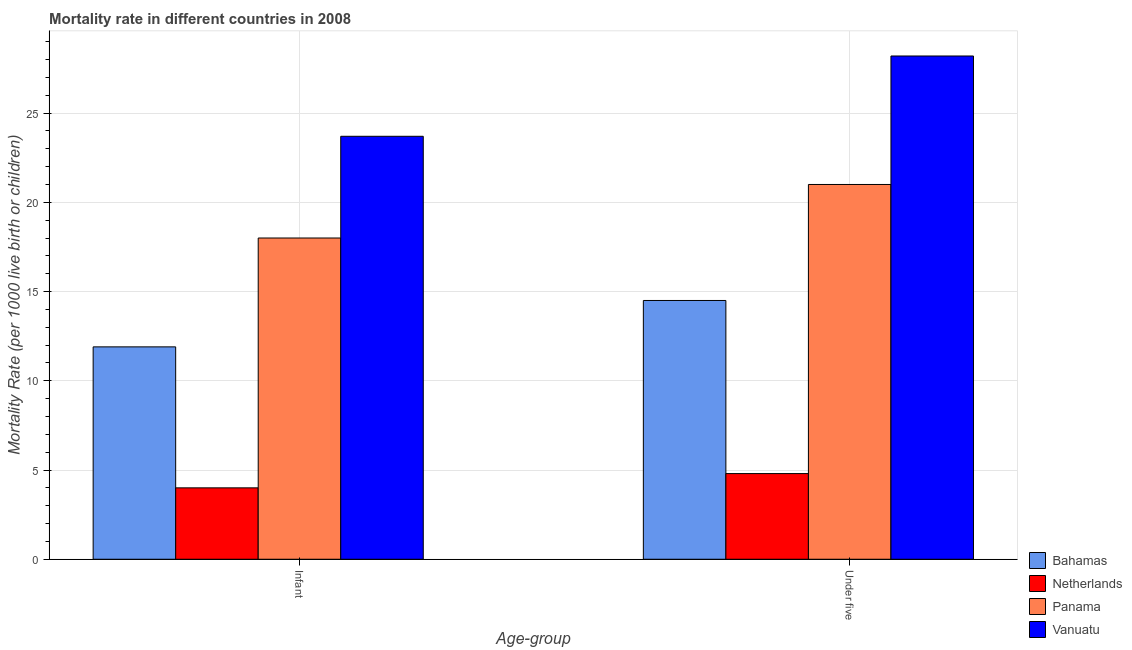How many different coloured bars are there?
Give a very brief answer. 4. Are the number of bars per tick equal to the number of legend labels?
Make the answer very short. Yes. Are the number of bars on each tick of the X-axis equal?
Offer a terse response. Yes. What is the label of the 2nd group of bars from the left?
Make the answer very short. Under five. What is the under-5 mortality rate in Vanuatu?
Your answer should be very brief. 28.2. Across all countries, what is the maximum under-5 mortality rate?
Your answer should be compact. 28.2. Across all countries, what is the minimum under-5 mortality rate?
Give a very brief answer. 4.8. In which country was the infant mortality rate maximum?
Offer a terse response. Vanuatu. In which country was the under-5 mortality rate minimum?
Keep it short and to the point. Netherlands. What is the total under-5 mortality rate in the graph?
Make the answer very short. 68.5. What is the difference between the infant mortality rate in Bahamas and that in Netherlands?
Make the answer very short. 7.9. What is the difference between the under-5 mortality rate in Vanuatu and the infant mortality rate in Netherlands?
Offer a terse response. 24.2. What is the average infant mortality rate per country?
Provide a short and direct response. 14.4. What is the ratio of the under-5 mortality rate in Vanuatu to that in Netherlands?
Your answer should be very brief. 5.88. In how many countries, is the infant mortality rate greater than the average infant mortality rate taken over all countries?
Provide a short and direct response. 2. What does the 4th bar from the left in Infant represents?
Your answer should be compact. Vanuatu. What does the 4th bar from the right in Infant represents?
Provide a short and direct response. Bahamas. How many bars are there?
Your response must be concise. 8. Are all the bars in the graph horizontal?
Keep it short and to the point. No. How many countries are there in the graph?
Provide a short and direct response. 4. Does the graph contain grids?
Provide a short and direct response. Yes. How many legend labels are there?
Give a very brief answer. 4. What is the title of the graph?
Make the answer very short. Mortality rate in different countries in 2008. What is the label or title of the X-axis?
Give a very brief answer. Age-group. What is the label or title of the Y-axis?
Keep it short and to the point. Mortality Rate (per 1000 live birth or children). What is the Mortality Rate (per 1000 live birth or children) of Bahamas in Infant?
Give a very brief answer. 11.9. What is the Mortality Rate (per 1000 live birth or children) in Vanuatu in Infant?
Your answer should be compact. 23.7. What is the Mortality Rate (per 1000 live birth or children) in Netherlands in Under five?
Your response must be concise. 4.8. What is the Mortality Rate (per 1000 live birth or children) in Vanuatu in Under five?
Keep it short and to the point. 28.2. Across all Age-group, what is the maximum Mortality Rate (per 1000 live birth or children) of Panama?
Give a very brief answer. 21. Across all Age-group, what is the maximum Mortality Rate (per 1000 live birth or children) of Vanuatu?
Your answer should be very brief. 28.2. Across all Age-group, what is the minimum Mortality Rate (per 1000 live birth or children) in Panama?
Provide a succinct answer. 18. Across all Age-group, what is the minimum Mortality Rate (per 1000 live birth or children) in Vanuatu?
Ensure brevity in your answer.  23.7. What is the total Mortality Rate (per 1000 live birth or children) in Bahamas in the graph?
Your answer should be very brief. 26.4. What is the total Mortality Rate (per 1000 live birth or children) in Netherlands in the graph?
Make the answer very short. 8.8. What is the total Mortality Rate (per 1000 live birth or children) of Vanuatu in the graph?
Your answer should be very brief. 51.9. What is the difference between the Mortality Rate (per 1000 live birth or children) of Bahamas in Infant and that in Under five?
Ensure brevity in your answer.  -2.6. What is the difference between the Mortality Rate (per 1000 live birth or children) in Bahamas in Infant and the Mortality Rate (per 1000 live birth or children) in Vanuatu in Under five?
Offer a terse response. -16.3. What is the difference between the Mortality Rate (per 1000 live birth or children) of Netherlands in Infant and the Mortality Rate (per 1000 live birth or children) of Vanuatu in Under five?
Your response must be concise. -24.2. What is the average Mortality Rate (per 1000 live birth or children) in Bahamas per Age-group?
Offer a very short reply. 13.2. What is the average Mortality Rate (per 1000 live birth or children) of Panama per Age-group?
Offer a very short reply. 19.5. What is the average Mortality Rate (per 1000 live birth or children) of Vanuatu per Age-group?
Your answer should be very brief. 25.95. What is the difference between the Mortality Rate (per 1000 live birth or children) of Bahamas and Mortality Rate (per 1000 live birth or children) of Netherlands in Infant?
Keep it short and to the point. 7.9. What is the difference between the Mortality Rate (per 1000 live birth or children) in Bahamas and Mortality Rate (per 1000 live birth or children) in Panama in Infant?
Give a very brief answer. -6.1. What is the difference between the Mortality Rate (per 1000 live birth or children) of Netherlands and Mortality Rate (per 1000 live birth or children) of Panama in Infant?
Your answer should be compact. -14. What is the difference between the Mortality Rate (per 1000 live birth or children) in Netherlands and Mortality Rate (per 1000 live birth or children) in Vanuatu in Infant?
Offer a terse response. -19.7. What is the difference between the Mortality Rate (per 1000 live birth or children) in Panama and Mortality Rate (per 1000 live birth or children) in Vanuatu in Infant?
Give a very brief answer. -5.7. What is the difference between the Mortality Rate (per 1000 live birth or children) of Bahamas and Mortality Rate (per 1000 live birth or children) of Netherlands in Under five?
Offer a very short reply. 9.7. What is the difference between the Mortality Rate (per 1000 live birth or children) in Bahamas and Mortality Rate (per 1000 live birth or children) in Vanuatu in Under five?
Your answer should be very brief. -13.7. What is the difference between the Mortality Rate (per 1000 live birth or children) in Netherlands and Mortality Rate (per 1000 live birth or children) in Panama in Under five?
Your response must be concise. -16.2. What is the difference between the Mortality Rate (per 1000 live birth or children) of Netherlands and Mortality Rate (per 1000 live birth or children) of Vanuatu in Under five?
Provide a short and direct response. -23.4. What is the ratio of the Mortality Rate (per 1000 live birth or children) of Bahamas in Infant to that in Under five?
Keep it short and to the point. 0.82. What is the ratio of the Mortality Rate (per 1000 live birth or children) of Netherlands in Infant to that in Under five?
Make the answer very short. 0.83. What is the ratio of the Mortality Rate (per 1000 live birth or children) of Vanuatu in Infant to that in Under five?
Keep it short and to the point. 0.84. What is the difference between the highest and the second highest Mortality Rate (per 1000 live birth or children) of Bahamas?
Keep it short and to the point. 2.6. What is the difference between the highest and the second highest Mortality Rate (per 1000 live birth or children) in Netherlands?
Your answer should be compact. 0.8. 